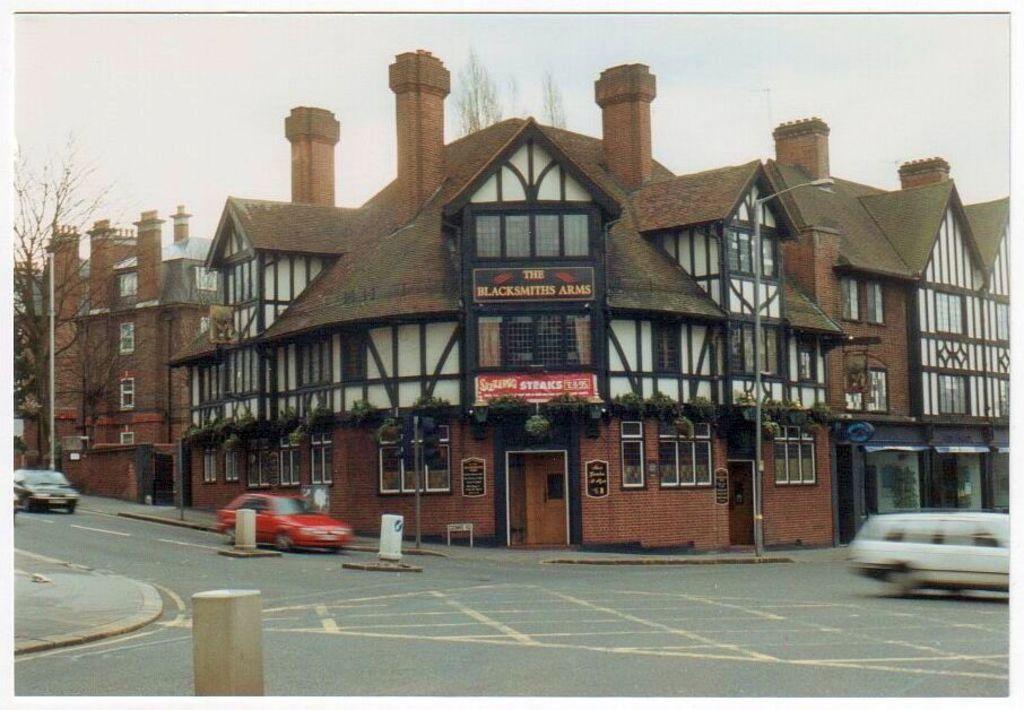Can you describe this image briefly? This is a street view of a building I can see some boards on a building with some text. I can see a dried tree on the left hand side of the image. I can see a road at the bottom of the image. I can see some cars on the road, I can see some pillar like objects at the bottom of the image on the road. 